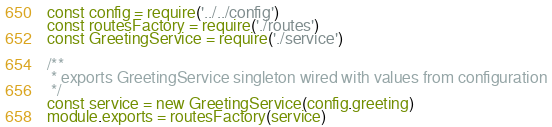Convert code to text. <code><loc_0><loc_0><loc_500><loc_500><_JavaScript_>const config = require('../../config')
const routesFactory = require('./routes')
const GreetingService = require('./service')

/**
 * exports GreetingService singleton wired with values from configuration
 */
const service = new GreetingService(config.greeting)
module.exports = routesFactory(service)
</code> 